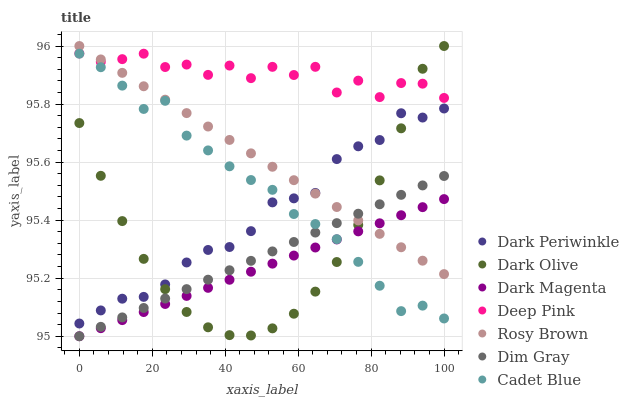Does Dark Magenta have the minimum area under the curve?
Answer yes or no. Yes. Does Deep Pink have the maximum area under the curve?
Answer yes or no. Yes. Does Dark Olive have the minimum area under the curve?
Answer yes or no. No. Does Dark Olive have the maximum area under the curve?
Answer yes or no. No. Is Rosy Brown the smoothest?
Answer yes or no. Yes. Is Deep Pink the roughest?
Answer yes or no. Yes. Is Dark Magenta the smoothest?
Answer yes or no. No. Is Dark Magenta the roughest?
Answer yes or no. No. Does Dim Gray have the lowest value?
Answer yes or no. Yes. Does Dark Olive have the lowest value?
Answer yes or no. No. Does Rosy Brown have the highest value?
Answer yes or no. Yes. Does Dark Magenta have the highest value?
Answer yes or no. No. Is Dim Gray less than Dark Periwinkle?
Answer yes or no. Yes. Is Rosy Brown greater than Cadet Blue?
Answer yes or no. Yes. Does Dark Olive intersect Dim Gray?
Answer yes or no. Yes. Is Dark Olive less than Dim Gray?
Answer yes or no. No. Is Dark Olive greater than Dim Gray?
Answer yes or no. No. Does Dim Gray intersect Dark Periwinkle?
Answer yes or no. No. 